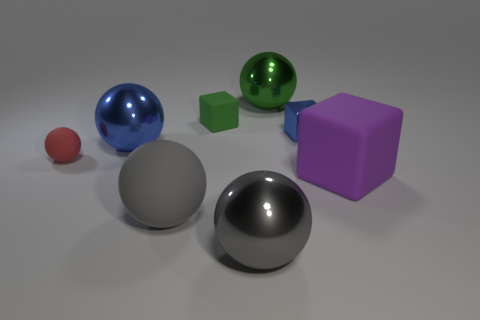Subtract all large gray metal balls. How many balls are left? 4 Subtract all green balls. How many balls are left? 4 Add 1 small blue shiny spheres. How many objects exist? 9 Subtract all purple spheres. Subtract all yellow blocks. How many spheres are left? 5 Subtract all balls. How many objects are left? 3 Subtract 0 gray cubes. How many objects are left? 8 Subtract all green cubes. Subtract all blue rubber things. How many objects are left? 7 Add 6 red things. How many red things are left? 7 Add 4 small cyan matte things. How many small cyan matte things exist? 4 